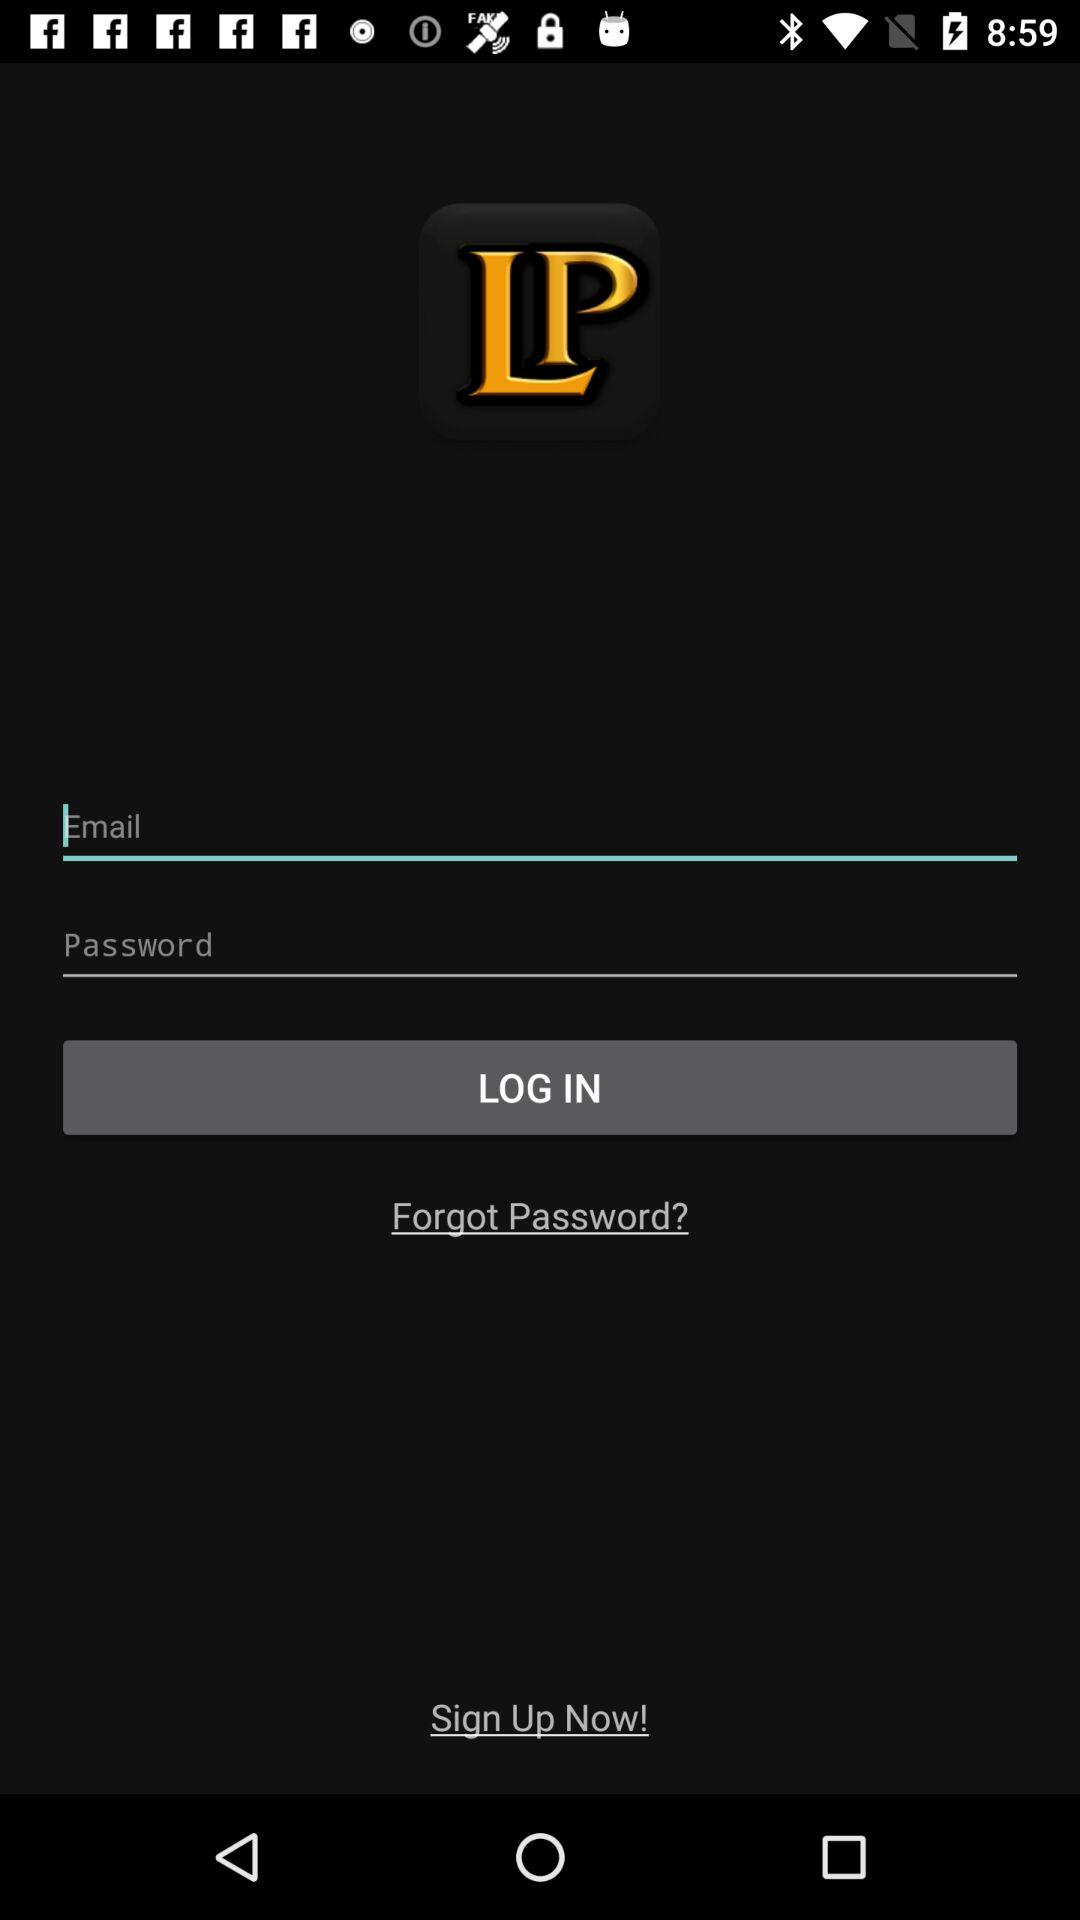What is the name of the application? The name of the application is LP. 